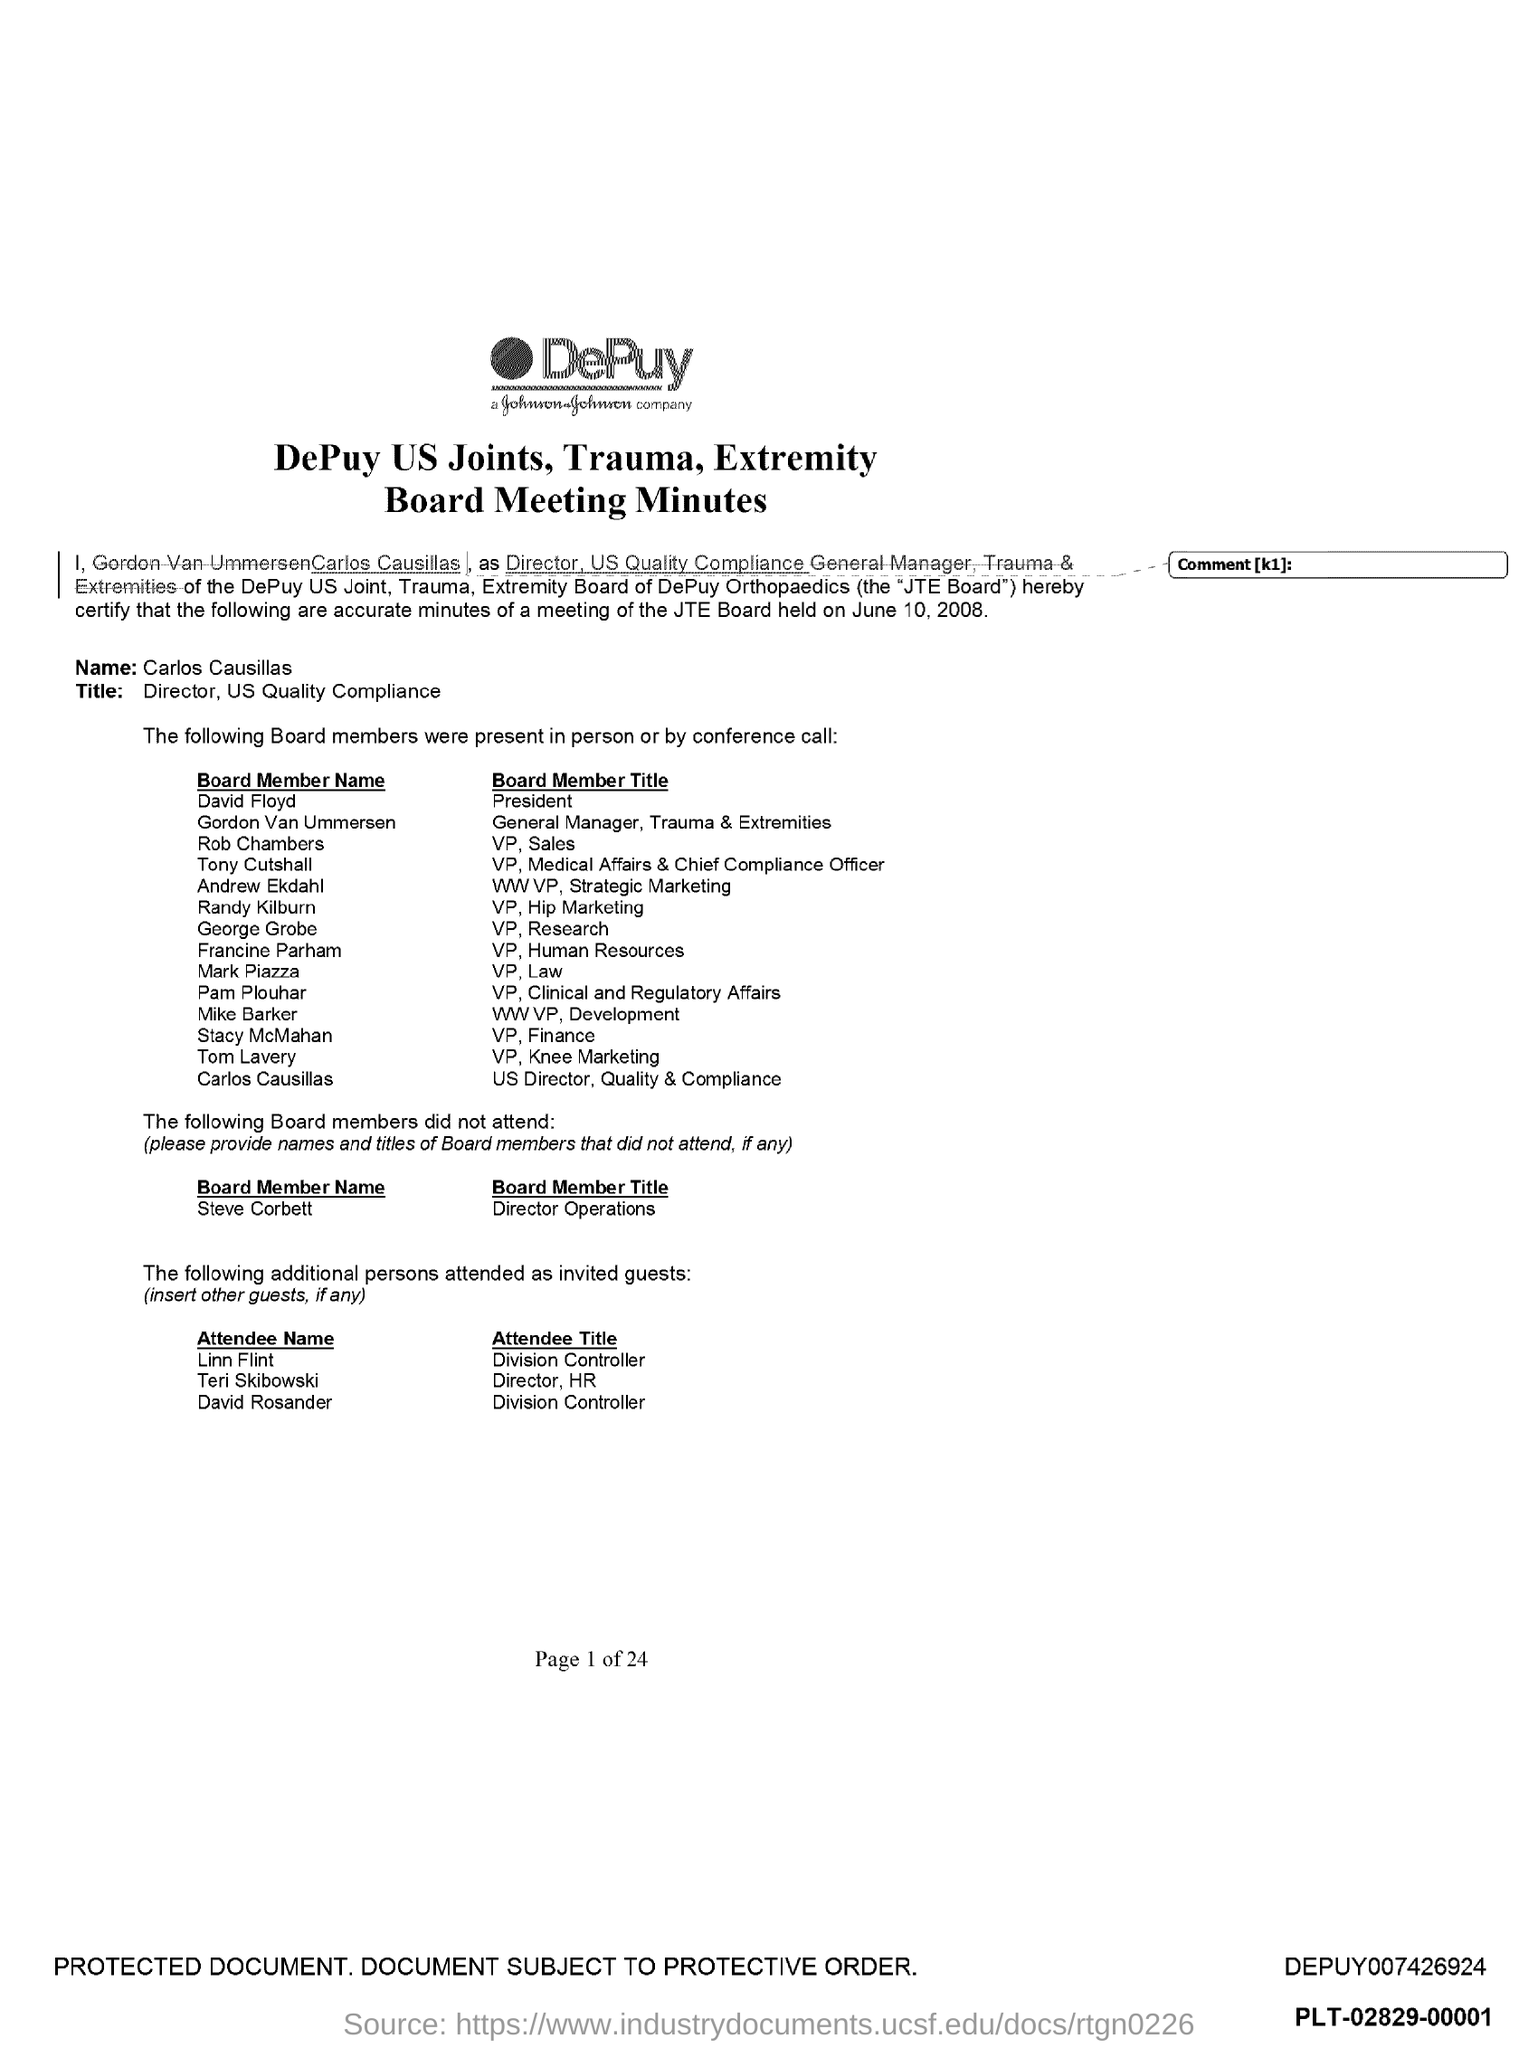List a handful of essential elements in this visual. Francine Parham is the Vice President of Human Resources at her company. The title of George Grobe is Vice President of Research. Randy Kilburn is the Vice President of Hip Marketing. Rob Chambers is the Vice President of Sales, as indicated by the title affixed to his name. As of my knowledge cutoff date of September 2021, Stacy McMahan held the position of Vice President of Finance. 